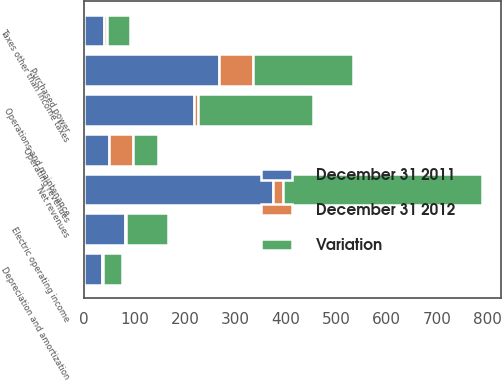Convert chart. <chart><loc_0><loc_0><loc_500><loc_500><stacked_bar_chart><ecel><fcel>Operating revenues<fcel>Purchased power<fcel>Net revenues<fcel>Operations and maintenance<fcel>Depreciation and amortization<fcel>Taxes other than income taxes<fcel>Electric operating income<nl><fcel>Variation<fcel>49<fcel>198<fcel>394<fcel>227<fcel>38<fcel>46<fcel>83<nl><fcel>December 31 2011<fcel>49<fcel>267<fcel>374<fcel>218<fcel>35<fcel>40<fcel>81<nl><fcel>December 31 2012<fcel>49<fcel>69<fcel>20<fcel>9<fcel>3<fcel>6<fcel>2<nl></chart> 